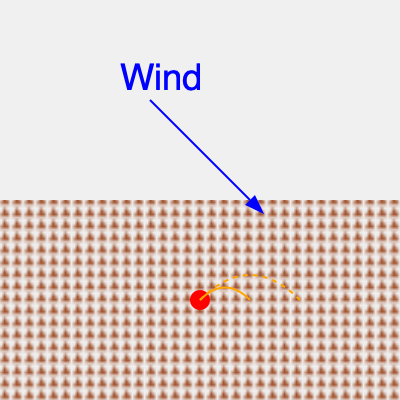Based on the diagram showing a mountainous terrain with a wind direction indicated, which path is the wildfire most likely to follow? To determine the most likely path of the wildfire, we need to consider several factors:

1. Wind direction: The blue arrow indicates the wind is blowing from the upper left to the lower right of the image.

2. Terrain: The brown triangular pattern represents mountainous terrain.

3. Fire origin: The red dot at the bottom center of the image marks the origin of the fire.

4. Potential spread paths: Two orange paths are shown - a solid line and a dashed line.

Given these factors:

a) Wind significantly influences wildfire spread, pushing flames and embers in the direction it's blowing.

b) Wildfires tend to spread faster uphill due to preheating of fuels ahead of the fire.

c) The solid orange line shows a shorter, steeper path up the mountain, aligning more closely with the wind direction.

d) The dashed orange line shows a longer, less steep path that doesn't align as closely with the wind direction.

Considering these points, the fire is most likely to follow the solid orange line. This path combines the influence of the wind direction with the tendency of fire to spread rapidly uphill.
Answer: The solid orange line 